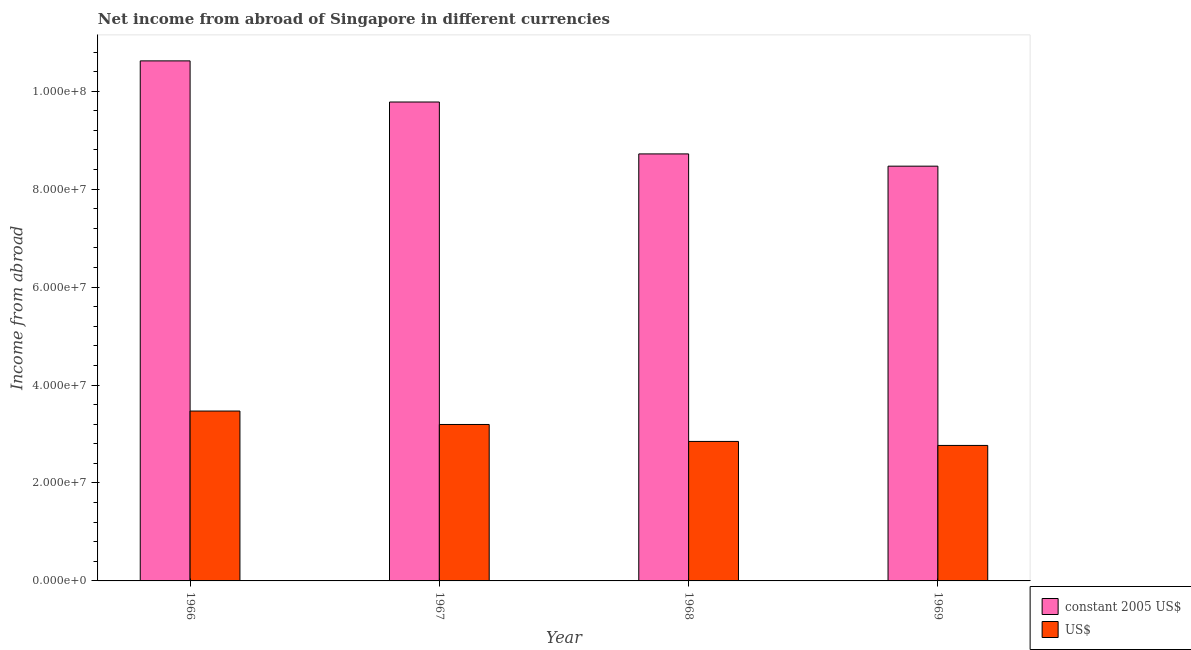How many different coloured bars are there?
Offer a terse response. 2. Are the number of bars on each tick of the X-axis equal?
Ensure brevity in your answer.  Yes. How many bars are there on the 2nd tick from the left?
Offer a very short reply. 2. What is the label of the 1st group of bars from the left?
Offer a very short reply. 1966. What is the income from abroad in constant 2005 us$ in 1967?
Provide a succinct answer. 9.78e+07. Across all years, what is the maximum income from abroad in us$?
Make the answer very short. 3.47e+07. Across all years, what is the minimum income from abroad in constant 2005 us$?
Provide a succinct answer. 8.47e+07. In which year was the income from abroad in us$ maximum?
Keep it short and to the point. 1966. In which year was the income from abroad in constant 2005 us$ minimum?
Give a very brief answer. 1969. What is the total income from abroad in constant 2005 us$ in the graph?
Offer a very short reply. 3.76e+08. What is the difference between the income from abroad in us$ in 1966 and that in 1968?
Give a very brief answer. 6.21e+06. What is the difference between the income from abroad in constant 2005 us$ in 1969 and the income from abroad in us$ in 1968?
Keep it short and to the point. -2.50e+06. What is the average income from abroad in constant 2005 us$ per year?
Your answer should be very brief. 9.40e+07. In how many years, is the income from abroad in constant 2005 us$ greater than 36000000 units?
Your response must be concise. 4. What is the ratio of the income from abroad in constant 2005 us$ in 1966 to that in 1969?
Provide a succinct answer. 1.25. Is the difference between the income from abroad in us$ in 1966 and 1969 greater than the difference between the income from abroad in constant 2005 us$ in 1966 and 1969?
Keep it short and to the point. No. What is the difference between the highest and the second highest income from abroad in constant 2005 us$?
Offer a terse response. 8.40e+06. What is the difference between the highest and the lowest income from abroad in constant 2005 us$?
Give a very brief answer. 2.15e+07. In how many years, is the income from abroad in us$ greater than the average income from abroad in us$ taken over all years?
Keep it short and to the point. 2. What does the 1st bar from the left in 1966 represents?
Give a very brief answer. Constant 2005 us$. What does the 2nd bar from the right in 1969 represents?
Give a very brief answer. Constant 2005 us$. How many bars are there?
Offer a very short reply. 8. Are all the bars in the graph horizontal?
Keep it short and to the point. No. What is the difference between two consecutive major ticks on the Y-axis?
Provide a succinct answer. 2.00e+07. Does the graph contain grids?
Offer a terse response. No. How many legend labels are there?
Your answer should be very brief. 2. How are the legend labels stacked?
Ensure brevity in your answer.  Vertical. What is the title of the graph?
Keep it short and to the point. Net income from abroad of Singapore in different currencies. Does "Agricultural land" appear as one of the legend labels in the graph?
Keep it short and to the point. No. What is the label or title of the Y-axis?
Make the answer very short. Income from abroad. What is the Income from abroad in constant 2005 US$ in 1966?
Ensure brevity in your answer.  1.06e+08. What is the Income from abroad of US$ in 1966?
Make the answer very short. 3.47e+07. What is the Income from abroad of constant 2005 US$ in 1967?
Provide a short and direct response. 9.78e+07. What is the Income from abroad of US$ in 1967?
Ensure brevity in your answer.  3.19e+07. What is the Income from abroad of constant 2005 US$ in 1968?
Keep it short and to the point. 8.72e+07. What is the Income from abroad in US$ in 1968?
Your answer should be compact. 2.85e+07. What is the Income from abroad in constant 2005 US$ in 1969?
Your answer should be very brief. 8.47e+07. What is the Income from abroad in US$ in 1969?
Your answer should be compact. 2.77e+07. Across all years, what is the maximum Income from abroad of constant 2005 US$?
Offer a very short reply. 1.06e+08. Across all years, what is the maximum Income from abroad of US$?
Provide a short and direct response. 3.47e+07. Across all years, what is the minimum Income from abroad of constant 2005 US$?
Your answer should be compact. 8.47e+07. Across all years, what is the minimum Income from abroad of US$?
Ensure brevity in your answer.  2.77e+07. What is the total Income from abroad in constant 2005 US$ in the graph?
Provide a succinct answer. 3.76e+08. What is the total Income from abroad in US$ in the graph?
Ensure brevity in your answer.  1.23e+08. What is the difference between the Income from abroad in constant 2005 US$ in 1966 and that in 1967?
Provide a succinct answer. 8.40e+06. What is the difference between the Income from abroad of US$ in 1966 and that in 1967?
Your answer should be compact. 2.74e+06. What is the difference between the Income from abroad of constant 2005 US$ in 1966 and that in 1968?
Offer a terse response. 1.90e+07. What is the difference between the Income from abroad of US$ in 1966 and that in 1968?
Offer a very short reply. 6.21e+06. What is the difference between the Income from abroad of constant 2005 US$ in 1966 and that in 1969?
Give a very brief answer. 2.15e+07. What is the difference between the Income from abroad in US$ in 1966 and that in 1969?
Your answer should be compact. 7.02e+06. What is the difference between the Income from abroad in constant 2005 US$ in 1967 and that in 1968?
Your answer should be compact. 1.06e+07. What is the difference between the Income from abroad of US$ in 1967 and that in 1968?
Offer a very short reply. 3.46e+06. What is the difference between the Income from abroad of constant 2005 US$ in 1967 and that in 1969?
Provide a succinct answer. 1.31e+07. What is the difference between the Income from abroad of US$ in 1967 and that in 1969?
Your response must be concise. 4.28e+06. What is the difference between the Income from abroad of constant 2005 US$ in 1968 and that in 1969?
Give a very brief answer. 2.50e+06. What is the difference between the Income from abroad of US$ in 1968 and that in 1969?
Offer a very short reply. 8.17e+05. What is the difference between the Income from abroad of constant 2005 US$ in 1966 and the Income from abroad of US$ in 1967?
Your answer should be very brief. 7.43e+07. What is the difference between the Income from abroad of constant 2005 US$ in 1966 and the Income from abroad of US$ in 1968?
Offer a very short reply. 7.77e+07. What is the difference between the Income from abroad of constant 2005 US$ in 1966 and the Income from abroad of US$ in 1969?
Keep it short and to the point. 7.85e+07. What is the difference between the Income from abroad in constant 2005 US$ in 1967 and the Income from abroad in US$ in 1968?
Your answer should be compact. 6.93e+07. What is the difference between the Income from abroad of constant 2005 US$ in 1967 and the Income from abroad of US$ in 1969?
Give a very brief answer. 7.01e+07. What is the difference between the Income from abroad of constant 2005 US$ in 1968 and the Income from abroad of US$ in 1969?
Make the answer very short. 5.95e+07. What is the average Income from abroad in constant 2005 US$ per year?
Provide a succinct answer. 9.40e+07. What is the average Income from abroad in US$ per year?
Offer a very short reply. 3.07e+07. In the year 1966, what is the difference between the Income from abroad of constant 2005 US$ and Income from abroad of US$?
Make the answer very short. 7.15e+07. In the year 1967, what is the difference between the Income from abroad of constant 2005 US$ and Income from abroad of US$?
Your response must be concise. 6.59e+07. In the year 1968, what is the difference between the Income from abroad of constant 2005 US$ and Income from abroad of US$?
Make the answer very short. 5.87e+07. In the year 1969, what is the difference between the Income from abroad of constant 2005 US$ and Income from abroad of US$?
Provide a succinct answer. 5.70e+07. What is the ratio of the Income from abroad of constant 2005 US$ in 1966 to that in 1967?
Your response must be concise. 1.09. What is the ratio of the Income from abroad of US$ in 1966 to that in 1967?
Your answer should be very brief. 1.09. What is the ratio of the Income from abroad in constant 2005 US$ in 1966 to that in 1968?
Make the answer very short. 1.22. What is the ratio of the Income from abroad in US$ in 1966 to that in 1968?
Your answer should be compact. 1.22. What is the ratio of the Income from abroad in constant 2005 US$ in 1966 to that in 1969?
Ensure brevity in your answer.  1.25. What is the ratio of the Income from abroad of US$ in 1966 to that in 1969?
Provide a succinct answer. 1.25. What is the ratio of the Income from abroad of constant 2005 US$ in 1967 to that in 1968?
Your response must be concise. 1.12. What is the ratio of the Income from abroad in US$ in 1967 to that in 1968?
Offer a terse response. 1.12. What is the ratio of the Income from abroad in constant 2005 US$ in 1967 to that in 1969?
Your answer should be very brief. 1.15. What is the ratio of the Income from abroad in US$ in 1967 to that in 1969?
Make the answer very short. 1.15. What is the ratio of the Income from abroad of constant 2005 US$ in 1968 to that in 1969?
Provide a short and direct response. 1.03. What is the ratio of the Income from abroad of US$ in 1968 to that in 1969?
Make the answer very short. 1.03. What is the difference between the highest and the second highest Income from abroad in constant 2005 US$?
Keep it short and to the point. 8.40e+06. What is the difference between the highest and the second highest Income from abroad of US$?
Your answer should be very brief. 2.74e+06. What is the difference between the highest and the lowest Income from abroad in constant 2005 US$?
Ensure brevity in your answer.  2.15e+07. What is the difference between the highest and the lowest Income from abroad in US$?
Offer a terse response. 7.02e+06. 